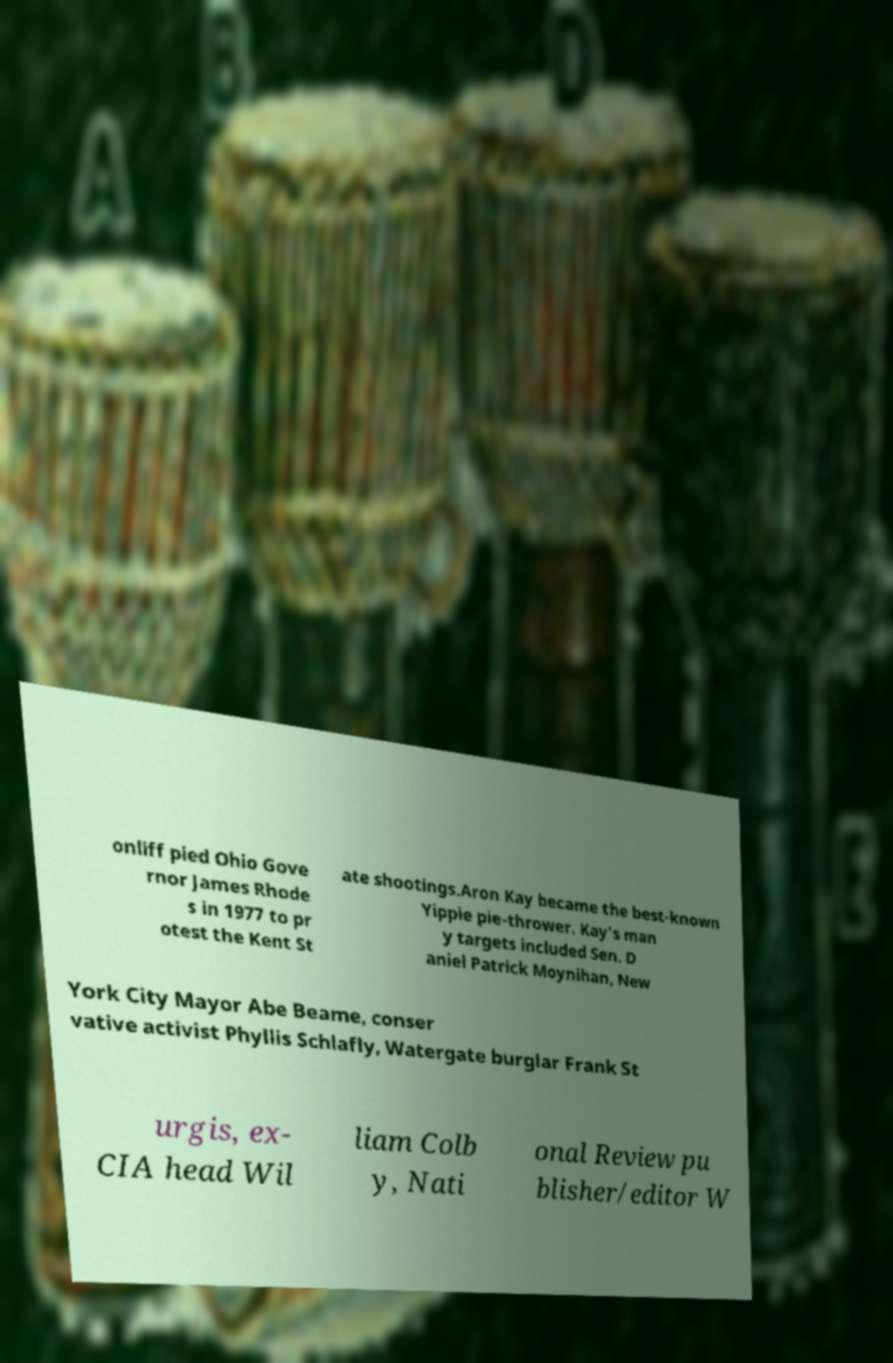Please identify and transcribe the text found in this image. onliff pied Ohio Gove rnor James Rhode s in 1977 to pr otest the Kent St ate shootings.Aron Kay became the best-known Yippie pie-thrower. Kay's man y targets included Sen. D aniel Patrick Moynihan, New York City Mayor Abe Beame, conser vative activist Phyllis Schlafly, Watergate burglar Frank St urgis, ex- CIA head Wil liam Colb y, Nati onal Review pu blisher/editor W 